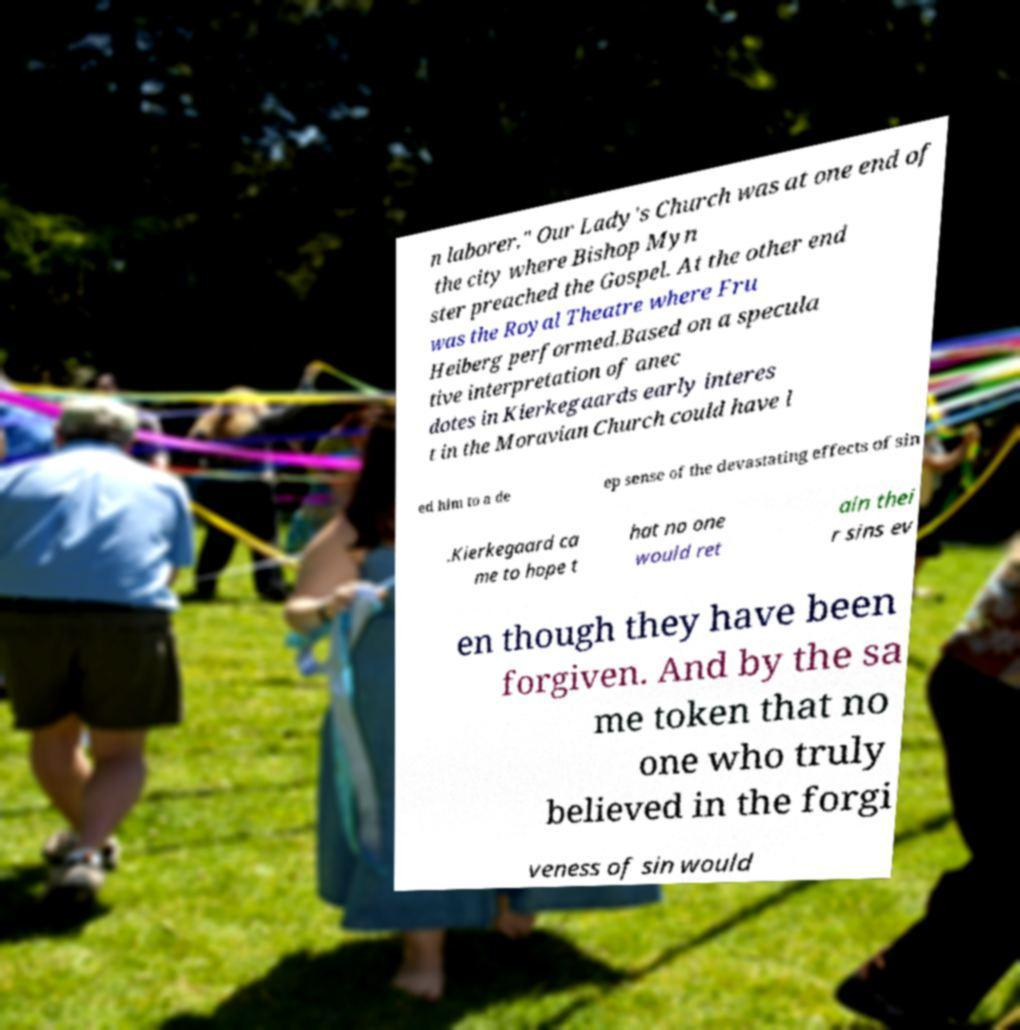Could you assist in decoding the text presented in this image and type it out clearly? n laborer." Our Lady's Church was at one end of the city where Bishop Myn ster preached the Gospel. At the other end was the Royal Theatre where Fru Heiberg performed.Based on a specula tive interpretation of anec dotes in Kierkegaards early interes t in the Moravian Church could have l ed him to a de ep sense of the devastating effects of sin .Kierkegaard ca me to hope t hat no one would ret ain thei r sins ev en though they have been forgiven. And by the sa me token that no one who truly believed in the forgi veness of sin would 